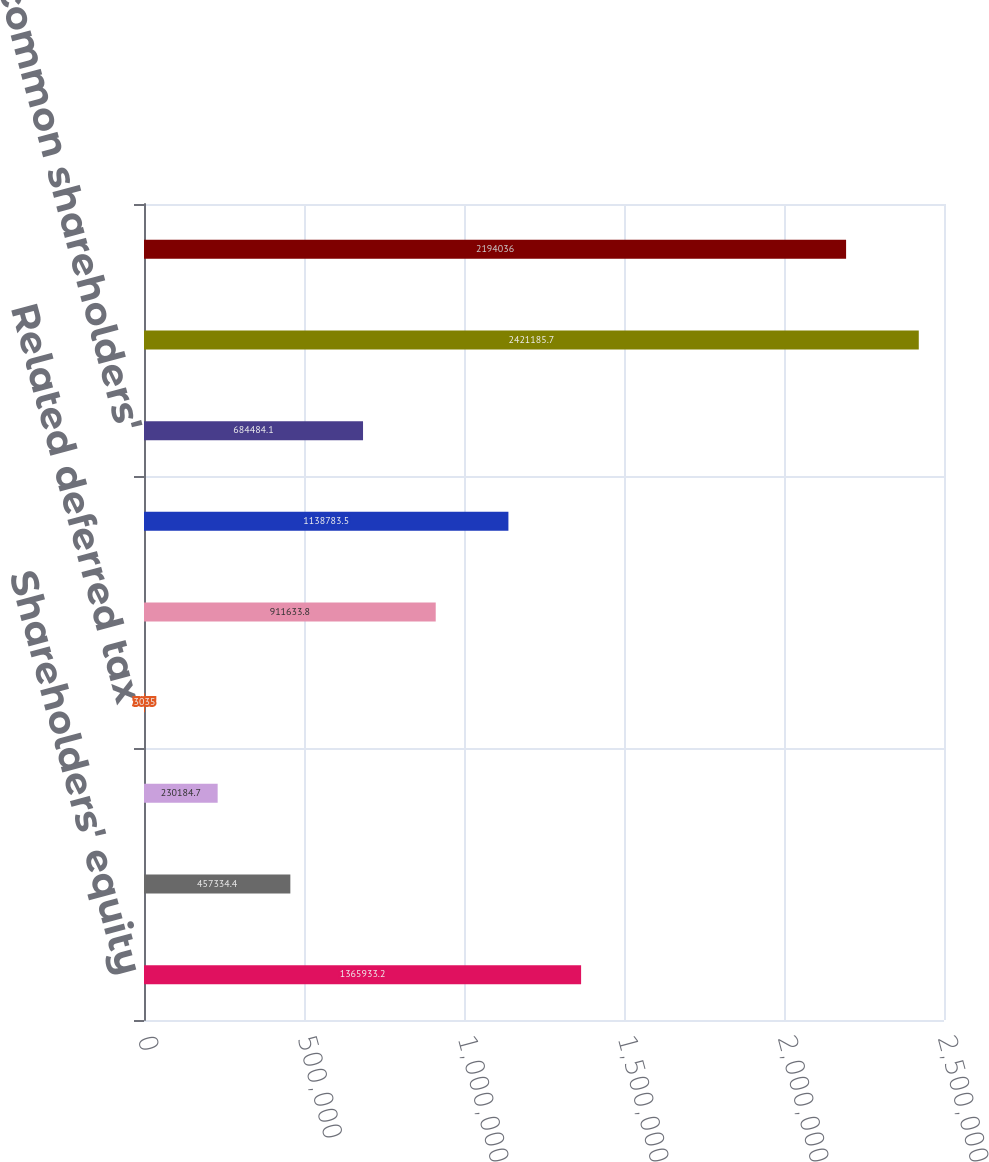Convert chart. <chart><loc_0><loc_0><loc_500><loc_500><bar_chart><fcel>Shareholders' equity<fcel>Goodwill<fcel>Intangible assets (excluding<fcel>Related deferred tax<fcel>Tangible shareholders' equity<fcel>Common shareholders' equity<fcel>Tangible common shareholders'<fcel>Assets<fcel>Tangible assets<nl><fcel>1.36593e+06<fcel>457334<fcel>230185<fcel>3035<fcel>911634<fcel>1.13878e+06<fcel>684484<fcel>2.42119e+06<fcel>2.19404e+06<nl></chart> 